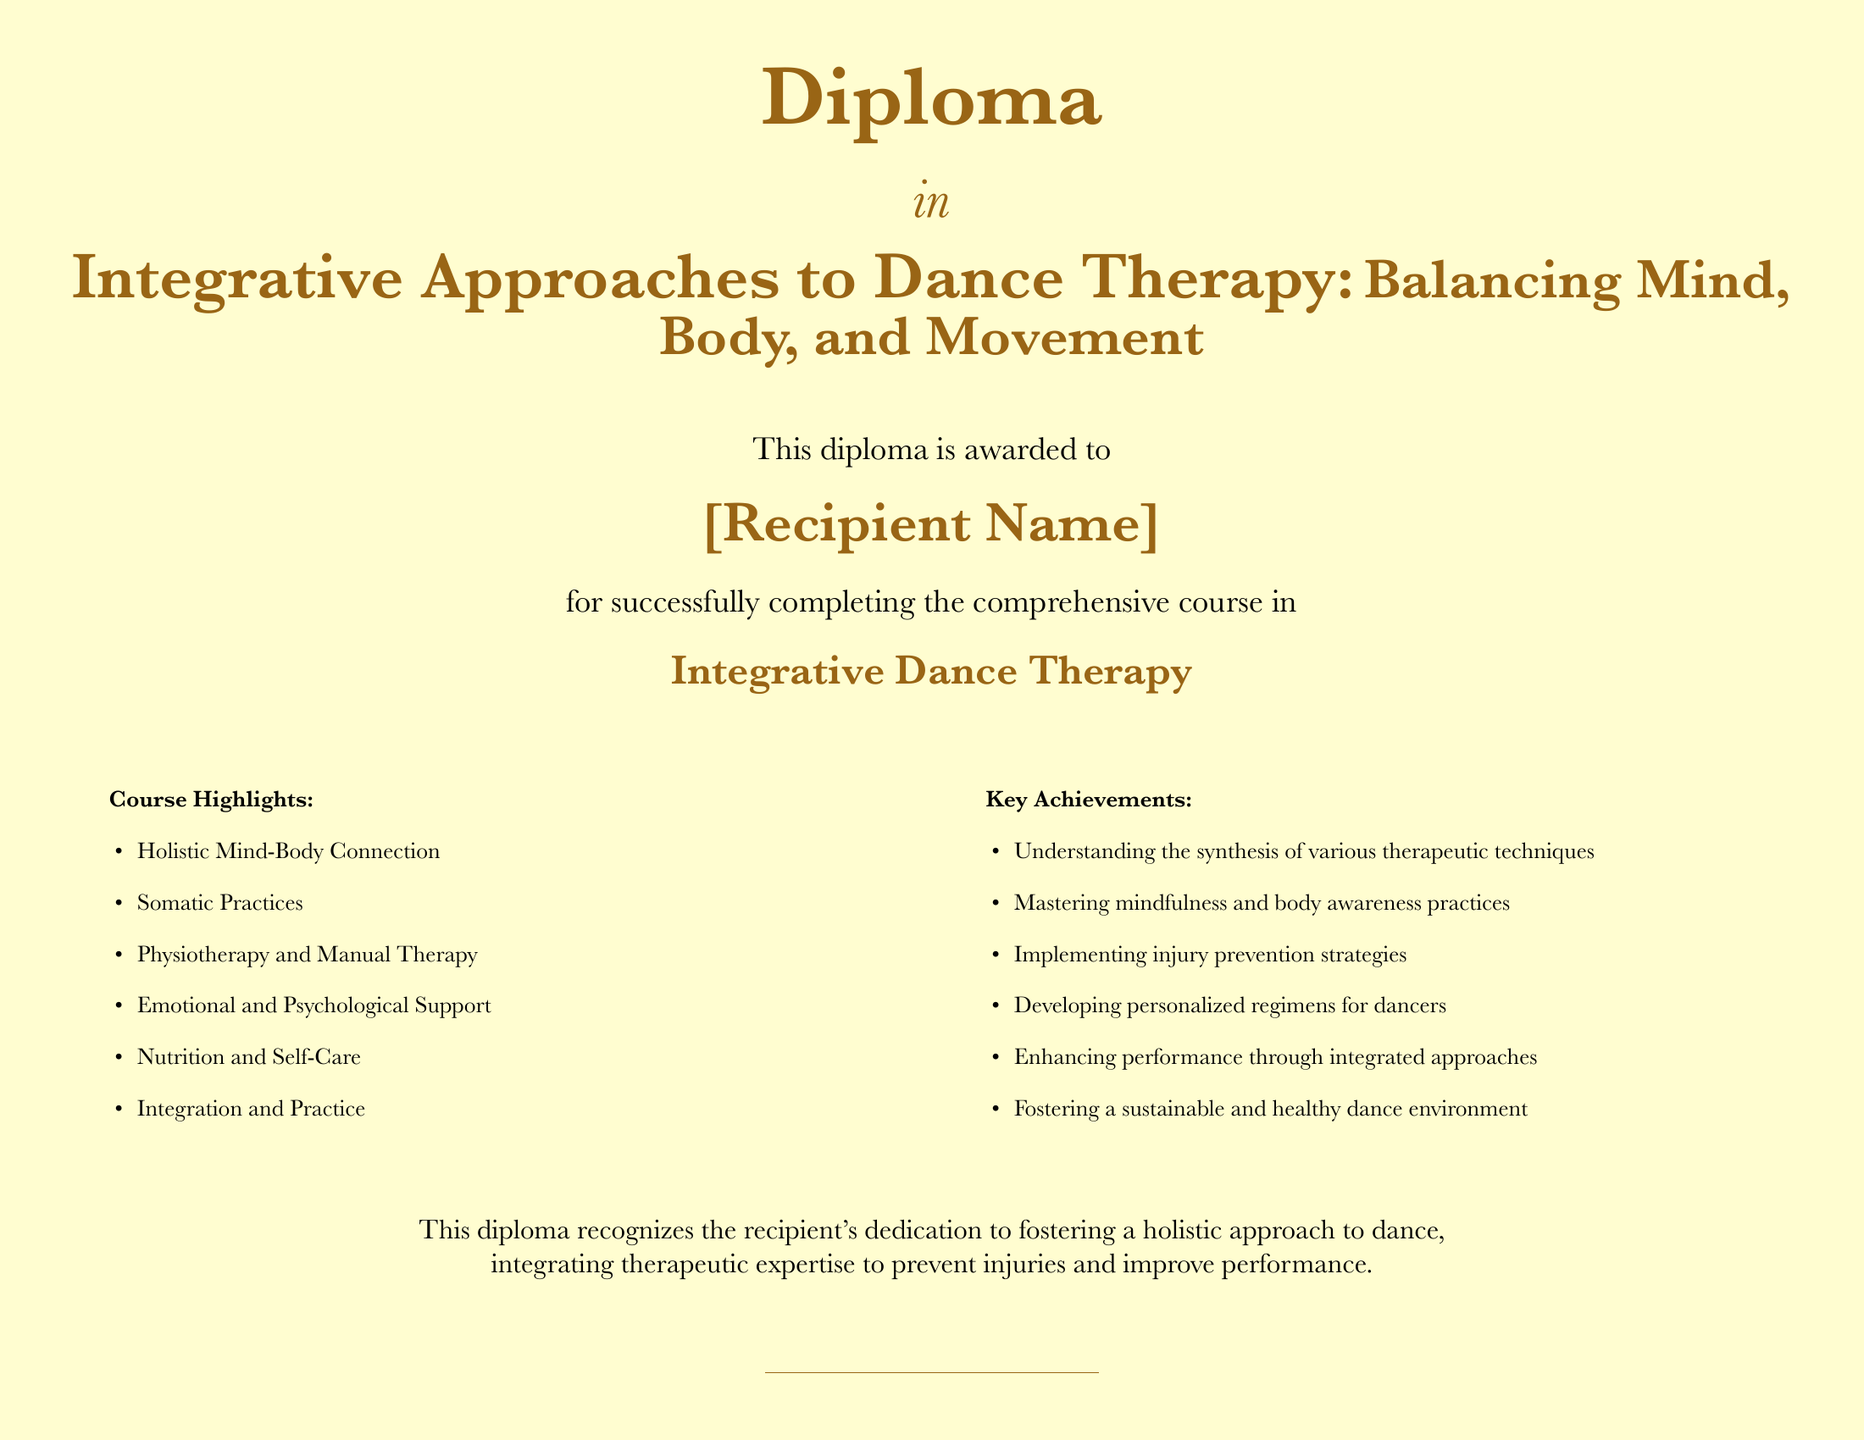What is the diploma awarded for? The diploma is awarded for successfully completing the comprehensive course in Integrative Dance Therapy.
Answer: Integrative Dance Therapy What is emphasized in the course highlights? The course highlights include various aspects such as the holistic mind-body connection and somatic practices.
Answer: Holistic Mind-Body Connection Who is recognized by this diploma? The diploma recognizes the recipient's dedication to fostering a holistic approach to dance.
Answer: The recipient What is one of the key achievements listed? The key achievements include understanding the synthesis of various therapeutic techniques.
Answer: Understanding the synthesis of various therapeutic techniques What date is mentioned at the bottom of the document? The date at the bottom of the document is the current day, as indicated by \today.
Answer: Today What color is used for the main font? The main color used for the text is golden brown.
Answer: Golden brown How many items are listed under course highlights? There are six items listed under the course highlights section.
Answer: Six What is the purpose of the diploma? The purpose is to acknowledge the integration of therapeutic expertise to prevent injuries and improve performance.
Answer: To prevent injuries and improve performance What title is given to the person signing the diploma? The title given is Program Director.
Answer: Program Director 